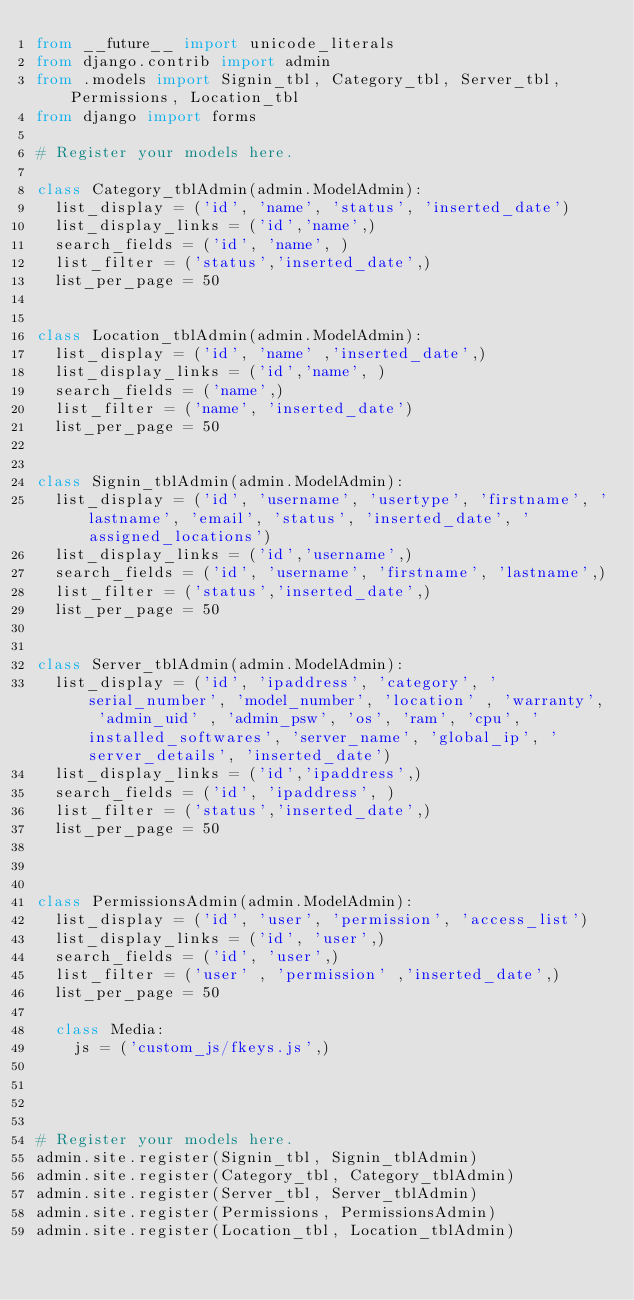Convert code to text. <code><loc_0><loc_0><loc_500><loc_500><_Python_>from __future__ import unicode_literals
from django.contrib import admin
from .models import Signin_tbl, Category_tbl, Server_tbl, Permissions, Location_tbl
from django import forms

# Register your models here.

class Category_tblAdmin(admin.ModelAdmin):
	list_display = ('id', 'name', 'status', 'inserted_date') 
	list_display_links = ('id','name',)
	search_fields = ('id', 'name', )
	list_filter = ('status','inserted_date',)
	list_per_page = 50	


class Location_tblAdmin(admin.ModelAdmin):
	list_display = ('id', 'name' ,'inserted_date',) 
	list_display_links = ('id','name', )
	search_fields = ('name',)
	list_filter = ('name', 'inserted_date')
	list_per_page = 50	

	
class Signin_tblAdmin(admin.ModelAdmin):
	list_display = ('id', 'username', 'usertype', 'firstname', 'lastname', 'email', 'status', 'inserted_date', 'assigned_locations') 
	list_display_links = ('id','username',)
	search_fields = ('id', 'username', 'firstname', 'lastname',)
	list_filter = ('status','inserted_date',)
	list_per_page = 50	

	
class Server_tblAdmin(admin.ModelAdmin):
	list_display = ('id', 'ipaddress', 'category', 'serial_number', 'model_number', 'location' , 'warranty', 'admin_uid' , 'admin_psw', 'os', 'ram', 'cpu', 'installed_softwares', 'server_name', 'global_ip', 'server_details', 'inserted_date') 
	list_display_links = ('id','ipaddress',)
	search_fields = ('id', 'ipaddress', )
	list_filter = ('status','inserted_date',)
	list_per_page = 50	
	
	
		
class PermissionsAdmin(admin.ModelAdmin):
	list_display = ('id', 'user', 'permission', 'access_list') 
	list_display_links = ('id', 'user',)
	search_fields = ('id', 'user',)
	list_filter = ('user' , 'permission' ,'inserted_date',)
	list_per_page = 50	
	
	class Media:
		js = ('custom_js/fkeys.js',)
	
	


# Register your models here.	
admin.site.register(Signin_tbl, Signin_tblAdmin)	
admin.site.register(Category_tbl, Category_tblAdmin)	
admin.site.register(Server_tbl, Server_tblAdmin)	
admin.site.register(Permissions, PermissionsAdmin)
admin.site.register(Location_tbl, Location_tblAdmin)
</code> 